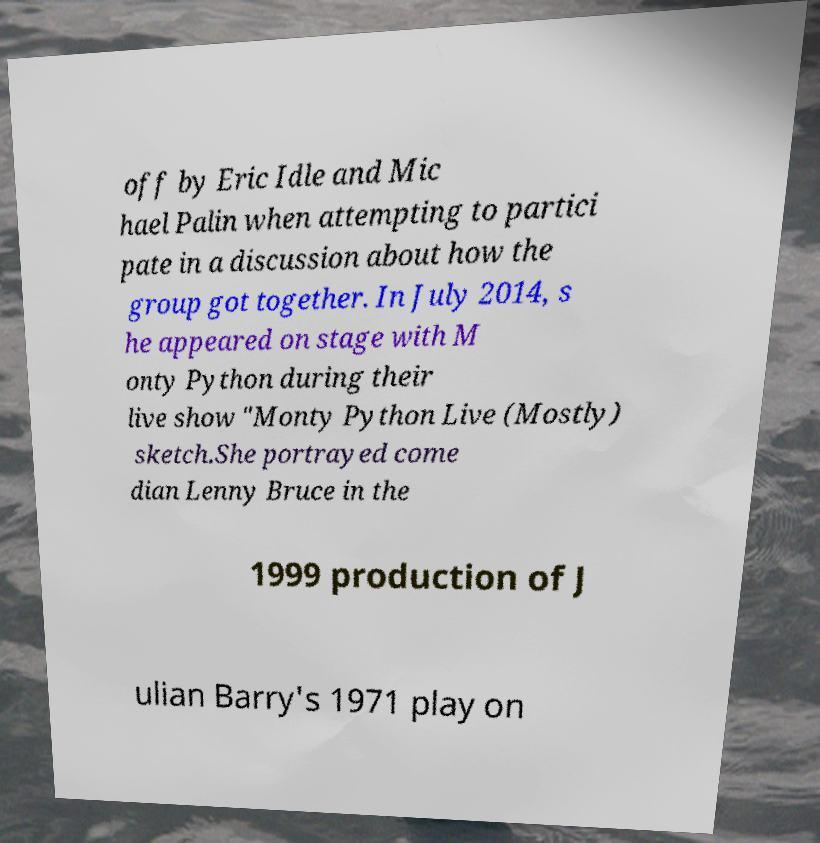Please read and relay the text visible in this image. What does it say? off by Eric Idle and Mic hael Palin when attempting to partici pate in a discussion about how the group got together. In July 2014, s he appeared on stage with M onty Python during their live show "Monty Python Live (Mostly) sketch.She portrayed come dian Lenny Bruce in the 1999 production of J ulian Barry's 1971 play on 